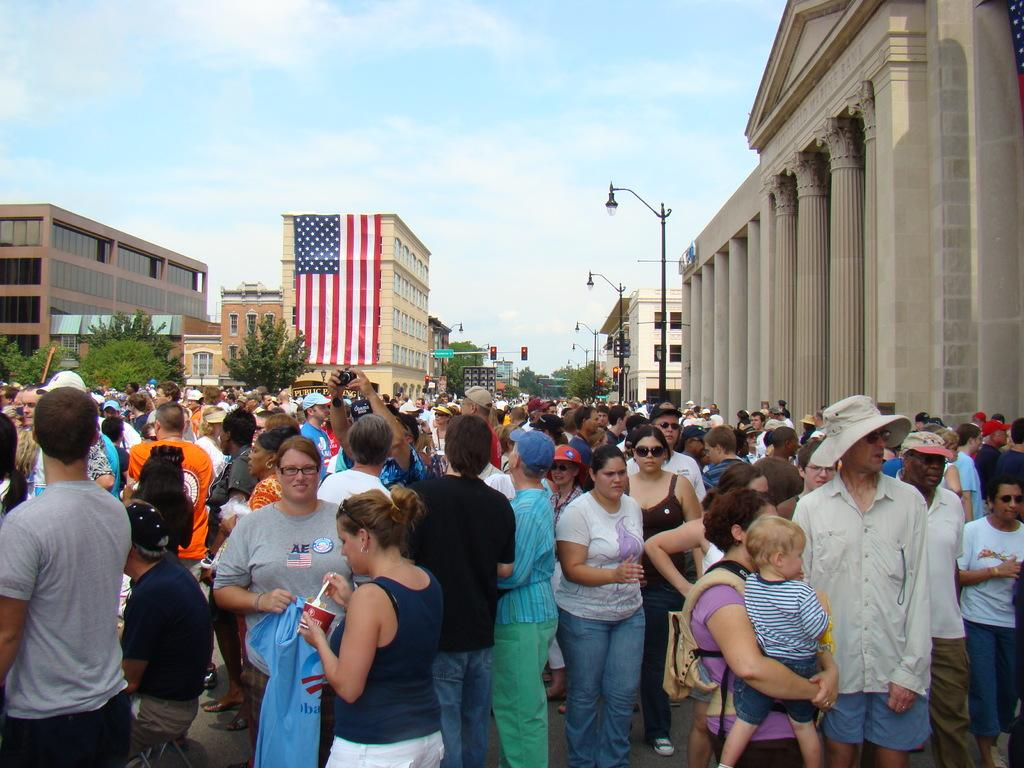What is happening on the road in the image? There is a crowd standing on the road in the image. What can be seen in the background of the image? Buildings, trees, and the sky are visible in the image. What type of infrastructure is present in the image? Street poles, street lights, traffic poles, traffic signals, and sign boards are present in the image. How does the root of the tree affect the traffic in the image? There is no root of a tree visible in the image, and therefore its impact on traffic cannot be determined. What type of whip is being used by the crowd in the image? There is no whip present in the image; the crowd is simply standing on the road. 